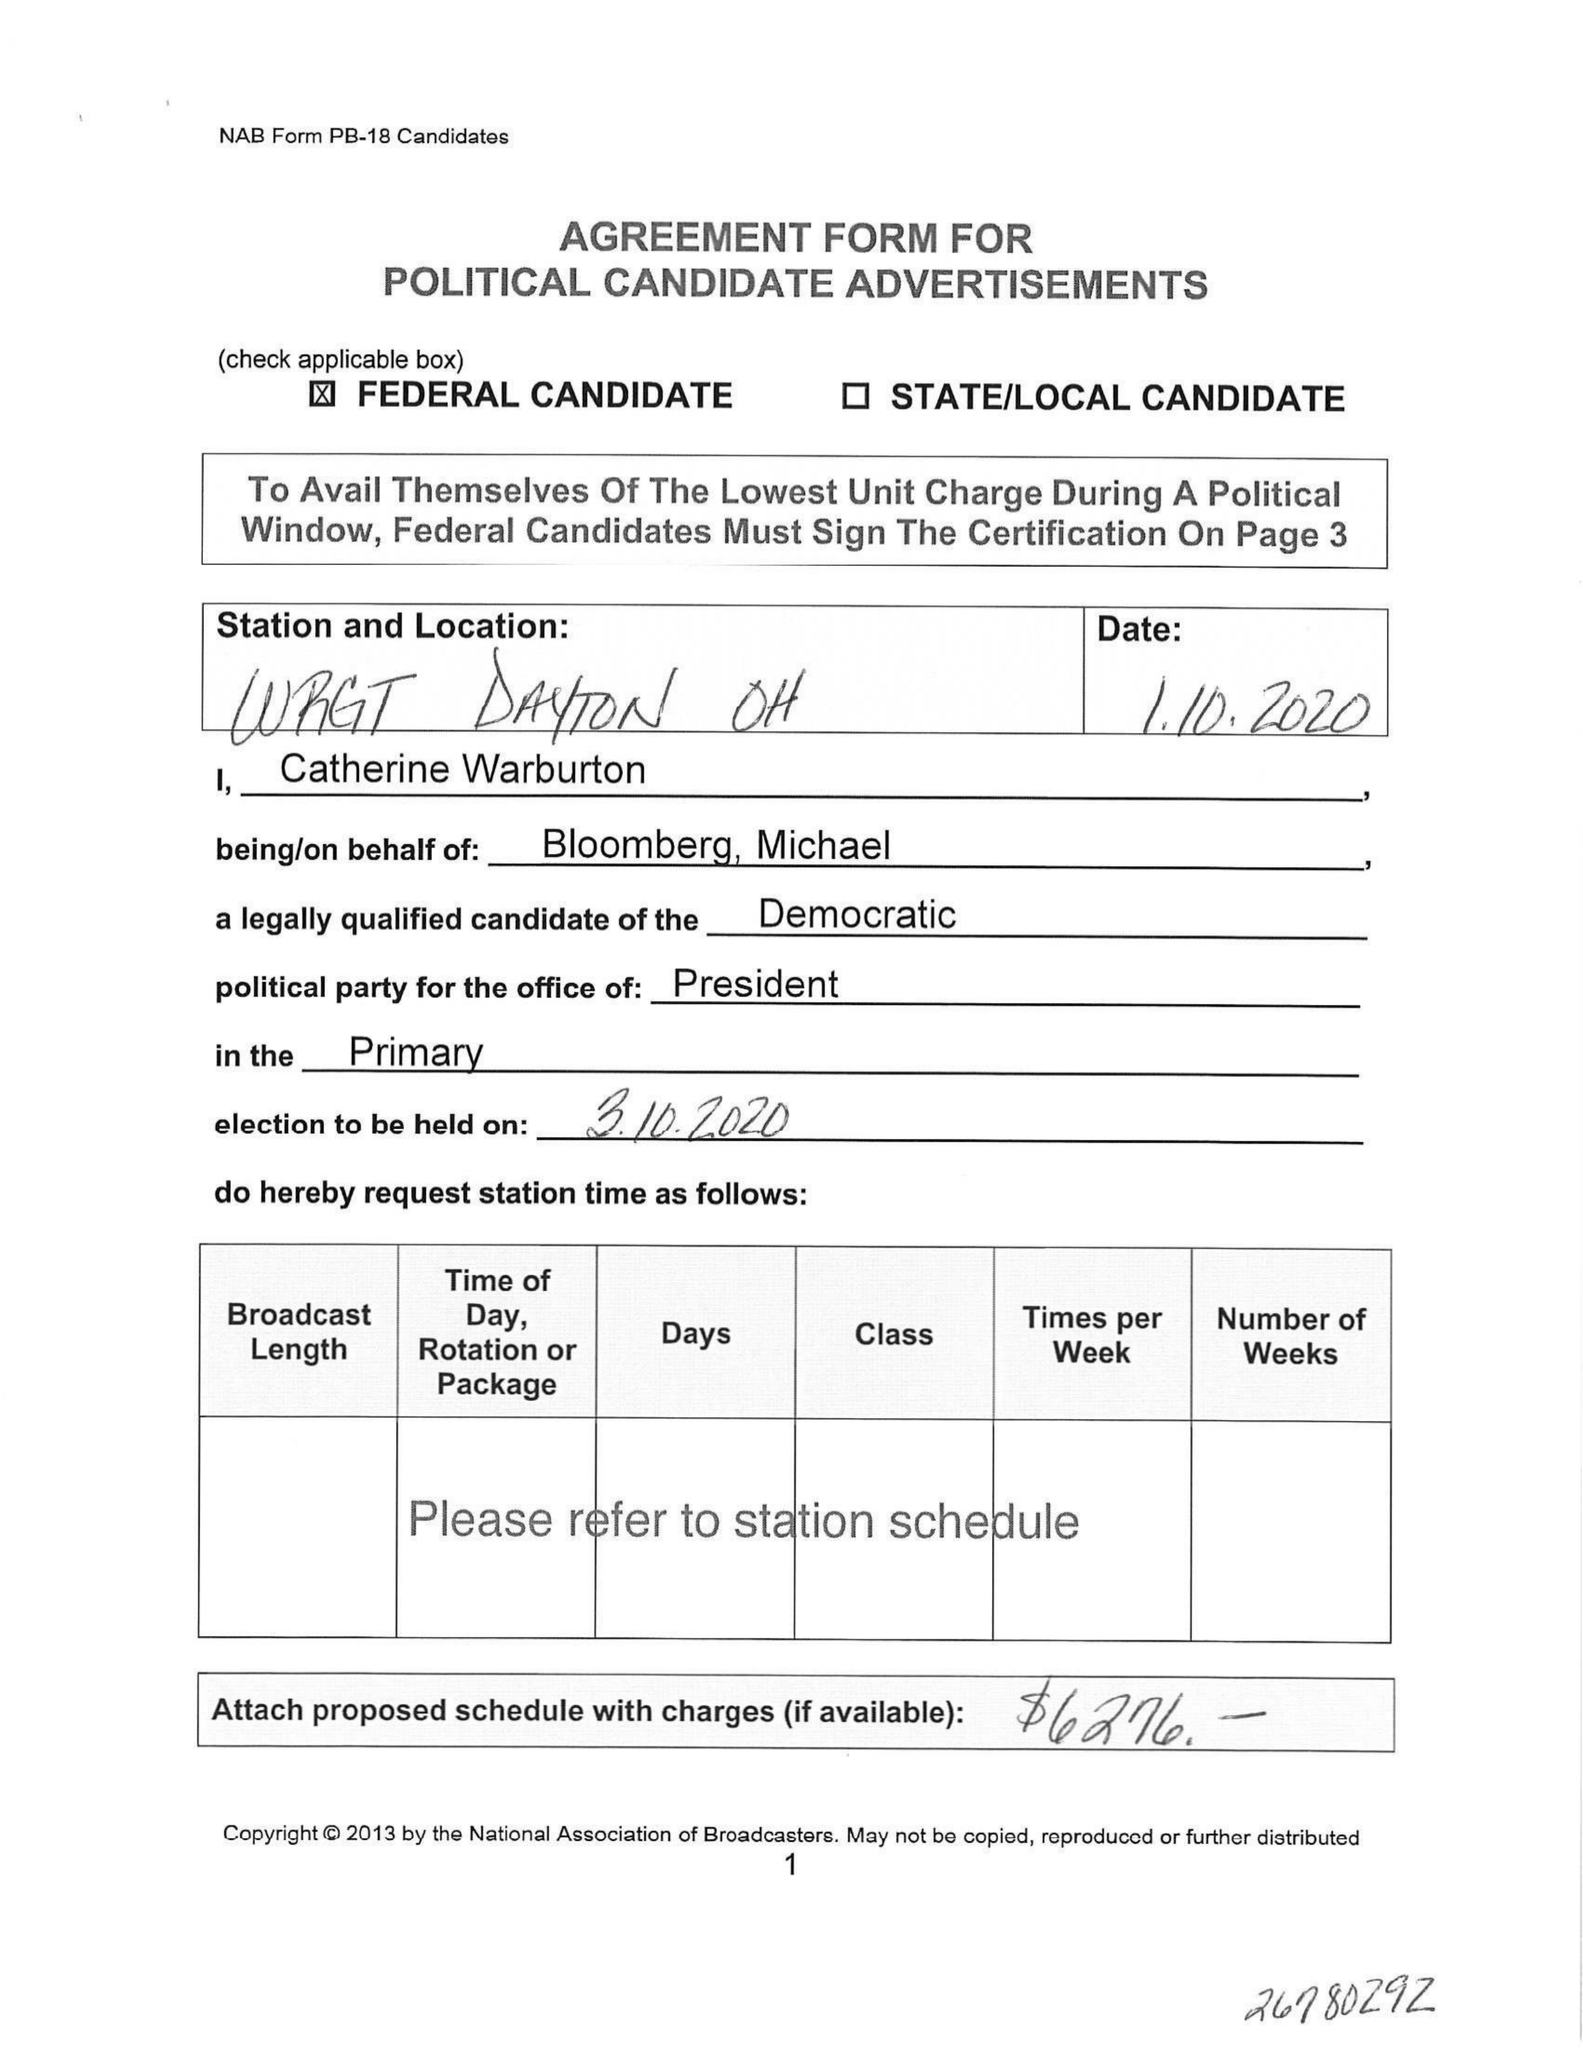What is the value for the contract_num?
Answer the question using a single word or phrase. None 